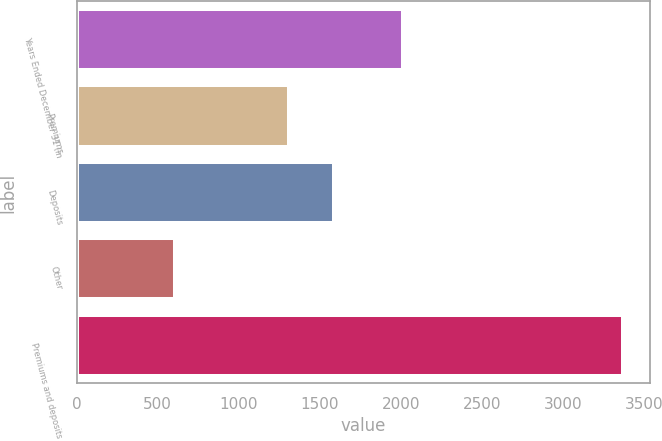Convert chart. <chart><loc_0><loc_0><loc_500><loc_500><bar_chart><fcel>Years Ended December 31 (in<fcel>Premiums<fcel>Deposits<fcel>Other<fcel>Premiums and deposits<nl><fcel>2015<fcel>1311<fcel>1587.2<fcel>608<fcel>3370<nl></chart> 